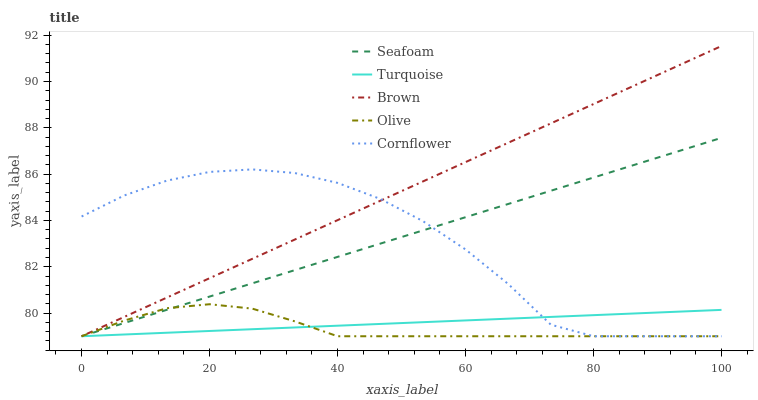Does Olive have the minimum area under the curve?
Answer yes or no. Yes. Does Brown have the maximum area under the curve?
Answer yes or no. Yes. Does Turquoise have the minimum area under the curve?
Answer yes or no. No. Does Turquoise have the maximum area under the curve?
Answer yes or no. No. Is Brown the smoothest?
Answer yes or no. Yes. Is Cornflower the roughest?
Answer yes or no. Yes. Is Turquoise the smoothest?
Answer yes or no. No. Is Turquoise the roughest?
Answer yes or no. No. Does Olive have the lowest value?
Answer yes or no. Yes. Does Brown have the highest value?
Answer yes or no. Yes. Does Turquoise have the highest value?
Answer yes or no. No. Does Brown intersect Cornflower?
Answer yes or no. Yes. Is Brown less than Cornflower?
Answer yes or no. No. Is Brown greater than Cornflower?
Answer yes or no. No. 